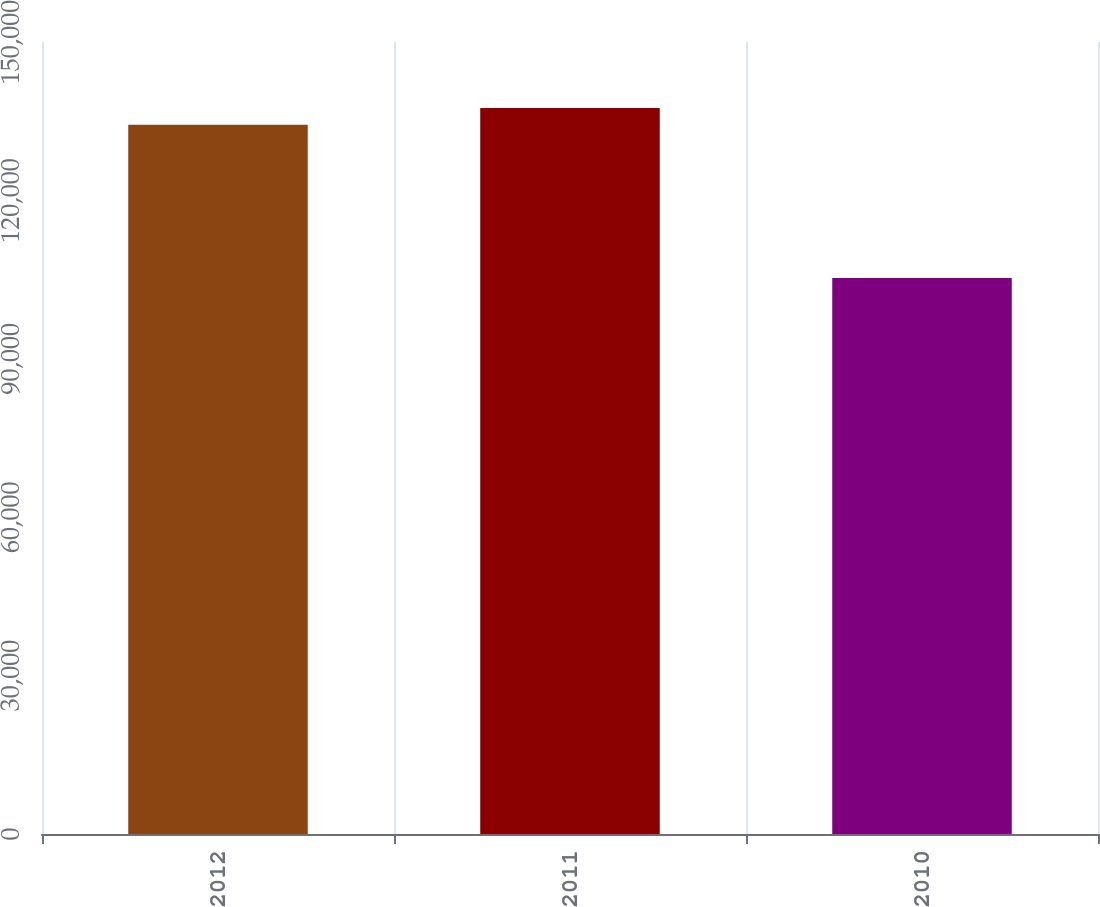<chart> <loc_0><loc_0><loc_500><loc_500><bar_chart><fcel>2012<fcel>2011<fcel>2010<nl><fcel>134349<fcel>137496<fcel>105286<nl></chart> 